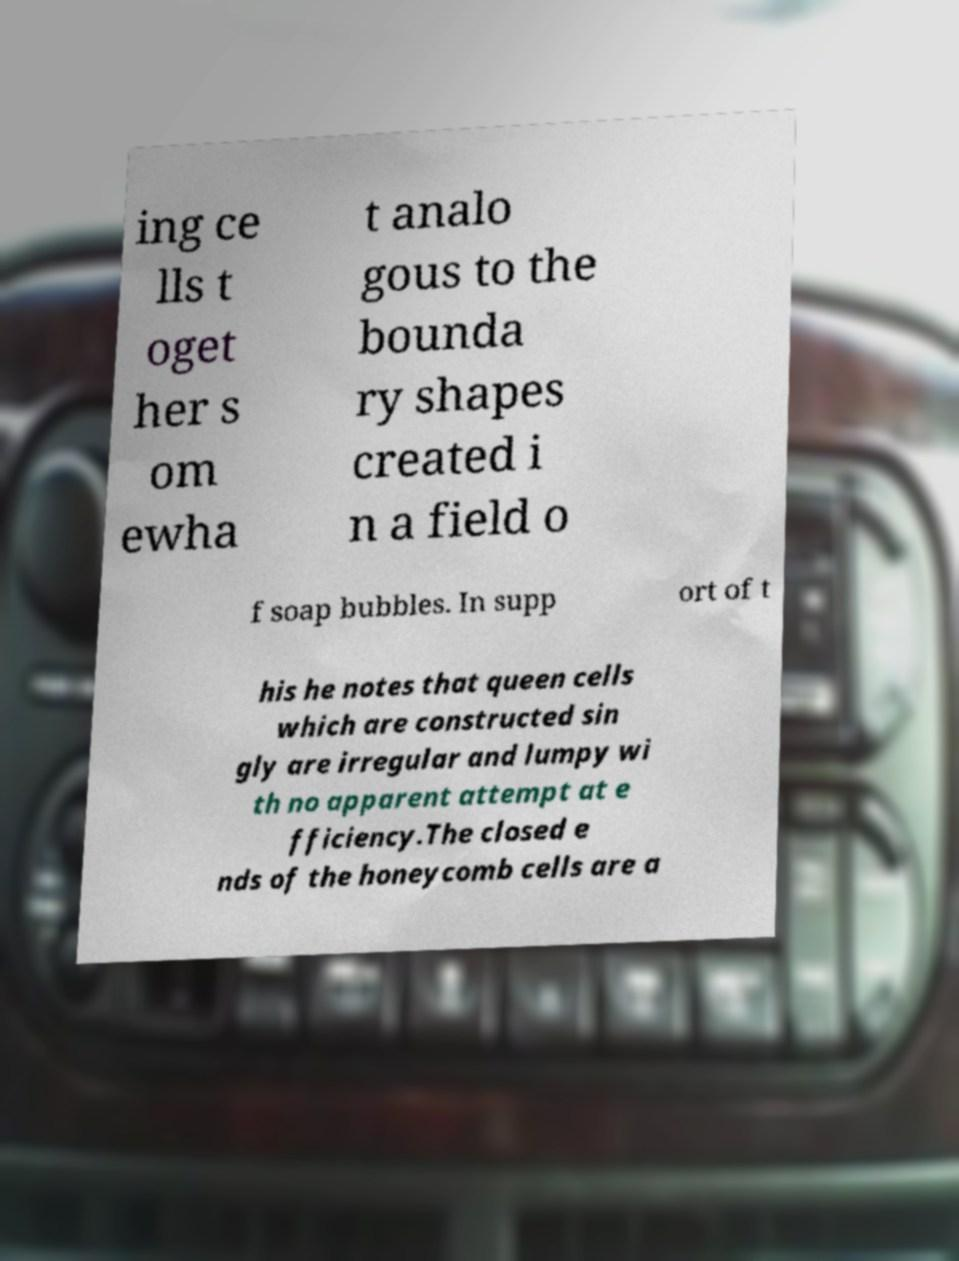What does the text in the image discuss? The text in the image appears to discuss structural aspects of cells, possibly in a biological or ecological context. It makes analogies to soap bubbles and mentions irregular and lumpy construction in relation to bees’ queen cells. It may be part of a larger discussion on natural structures or beekeeping practices. 